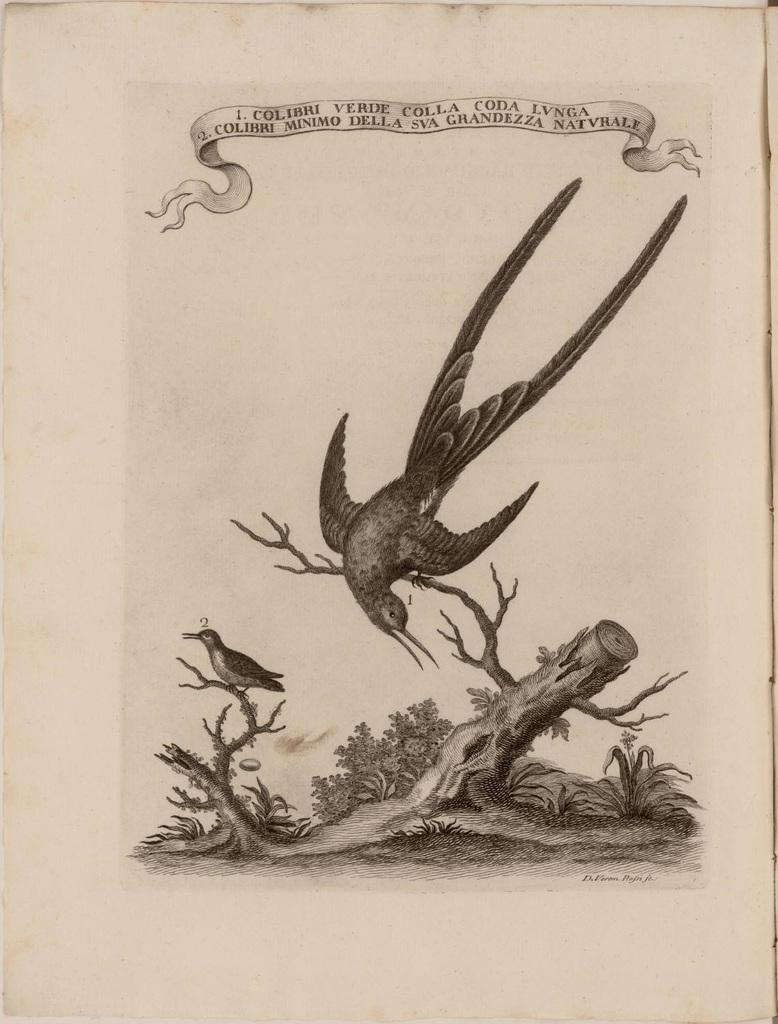What type of animals can be seen in the image? There are birds in the image. Where are the birds located? The birds are on a dry stem. What is written or displayed at the top of the image? There is text at the top of the image. What type of lamp can be seen hanging from the door in the image? There is no lamp or door present in the image; it features birds on a dry stem and text at the top. How many pickles are visible on the stem with the birds? There are no pickles present in the image; it features birds on a dry stem. 